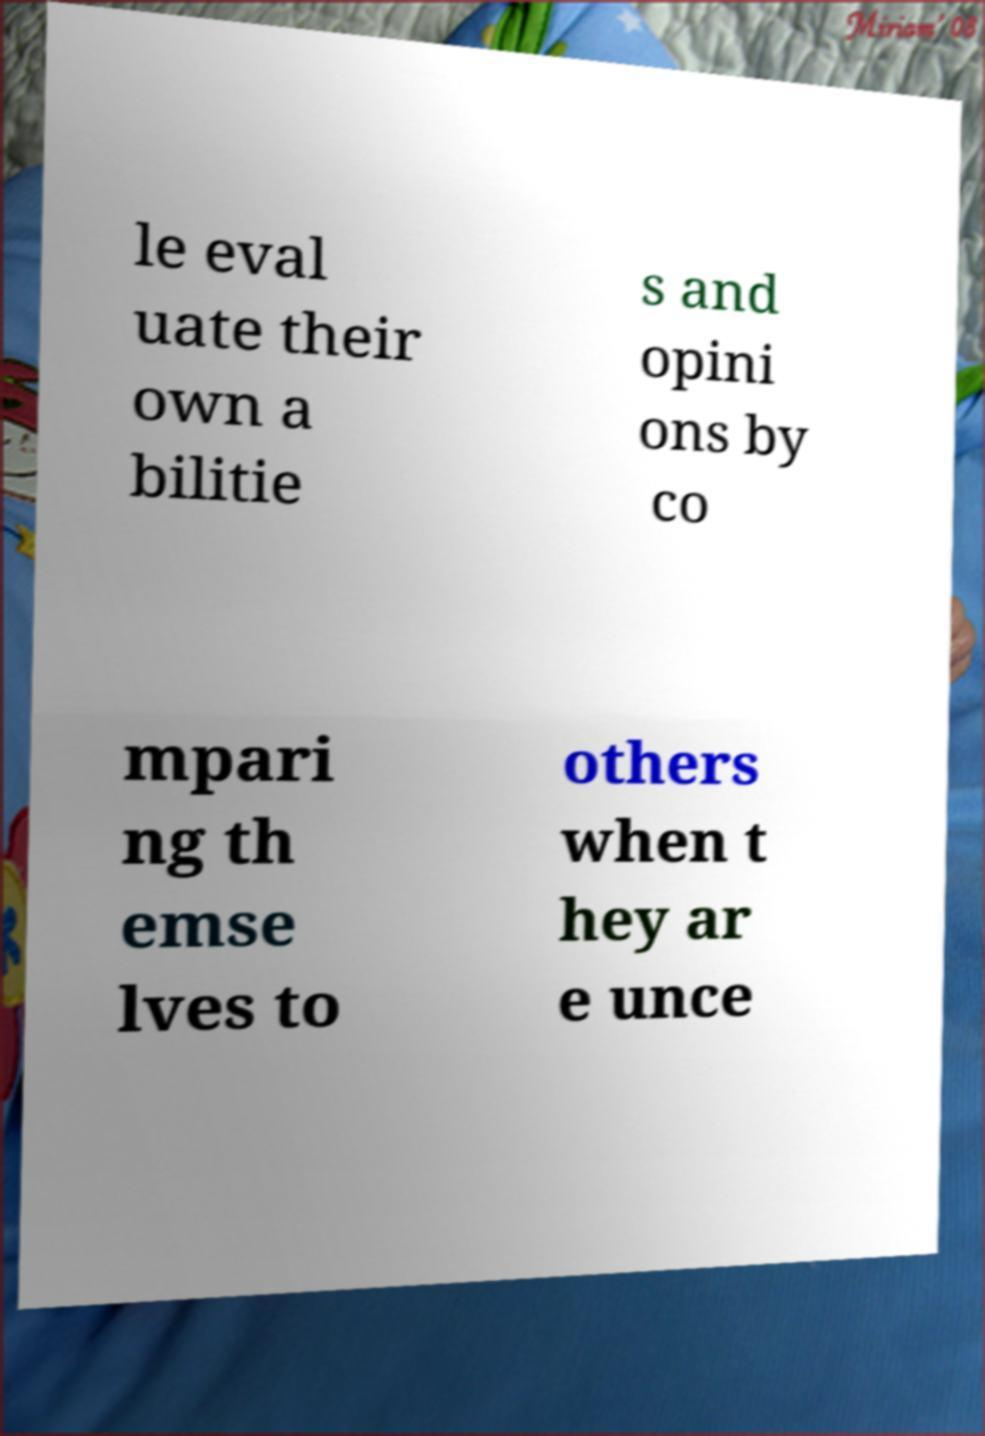For documentation purposes, I need the text within this image transcribed. Could you provide that? le eval uate their own a bilitie s and opini ons by co mpari ng th emse lves to others when t hey ar e unce 